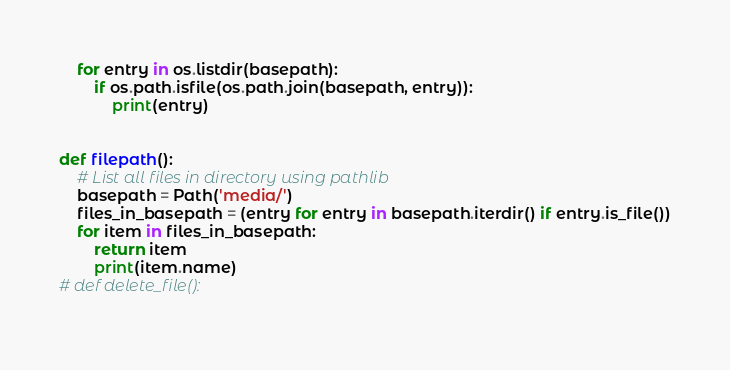Convert code to text. <code><loc_0><loc_0><loc_500><loc_500><_Python_>    for entry in os.listdir(basepath):
        if os.path.isfile(os.path.join(basepath, entry)):
            print(entry)


def filepath():    
    # List all files in directory using pathlib
    basepath = Path('media/')
    files_in_basepath = (entry for entry in basepath.iterdir() if entry.is_file())
    for item in files_in_basepath:
        return item
        print(item.name)
# def delete_file():
    </code> 